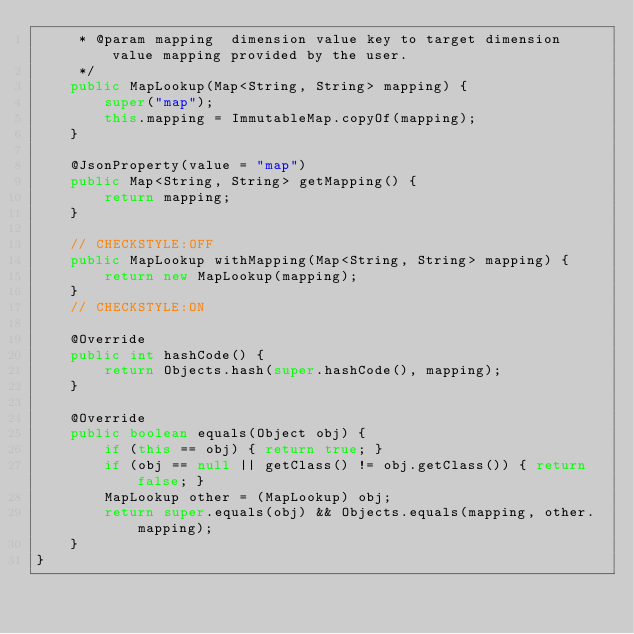<code> <loc_0><loc_0><loc_500><loc_500><_Java_>     * @param mapping  dimension value key to target dimension value mapping provided by the user.
     */
    public MapLookup(Map<String, String> mapping) {
        super("map");
        this.mapping = ImmutableMap.copyOf(mapping);
    }

    @JsonProperty(value = "map")
    public Map<String, String> getMapping() {
        return mapping;
    }

    // CHECKSTYLE:OFF
    public MapLookup withMapping(Map<String, String> mapping) {
        return new MapLookup(mapping);
    }
    // CHECKSTYLE:ON

    @Override
    public int hashCode() {
        return Objects.hash(super.hashCode(), mapping);
    }

    @Override
    public boolean equals(Object obj) {
        if (this == obj) { return true; }
        if (obj == null || getClass() != obj.getClass()) { return false; }
        MapLookup other = (MapLookup) obj;
        return super.equals(obj) && Objects.equals(mapping, other.mapping);
    }
}
</code> 